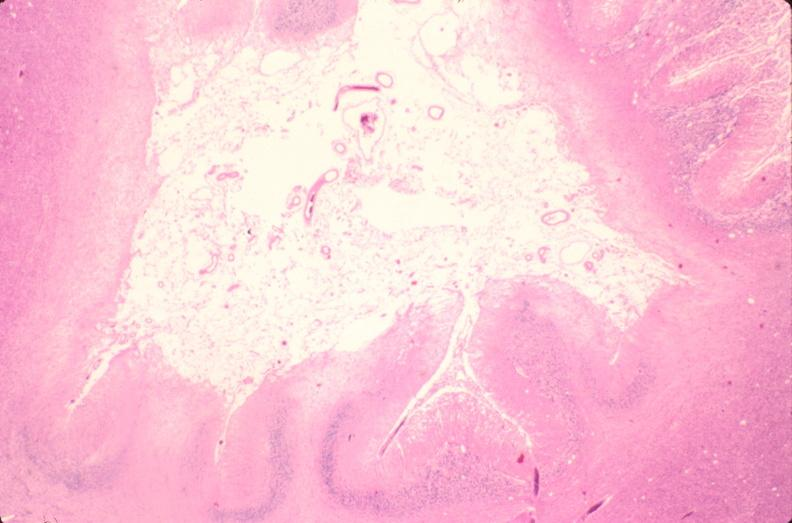what does this image show?
Answer the question using a single word or phrase. Brain 